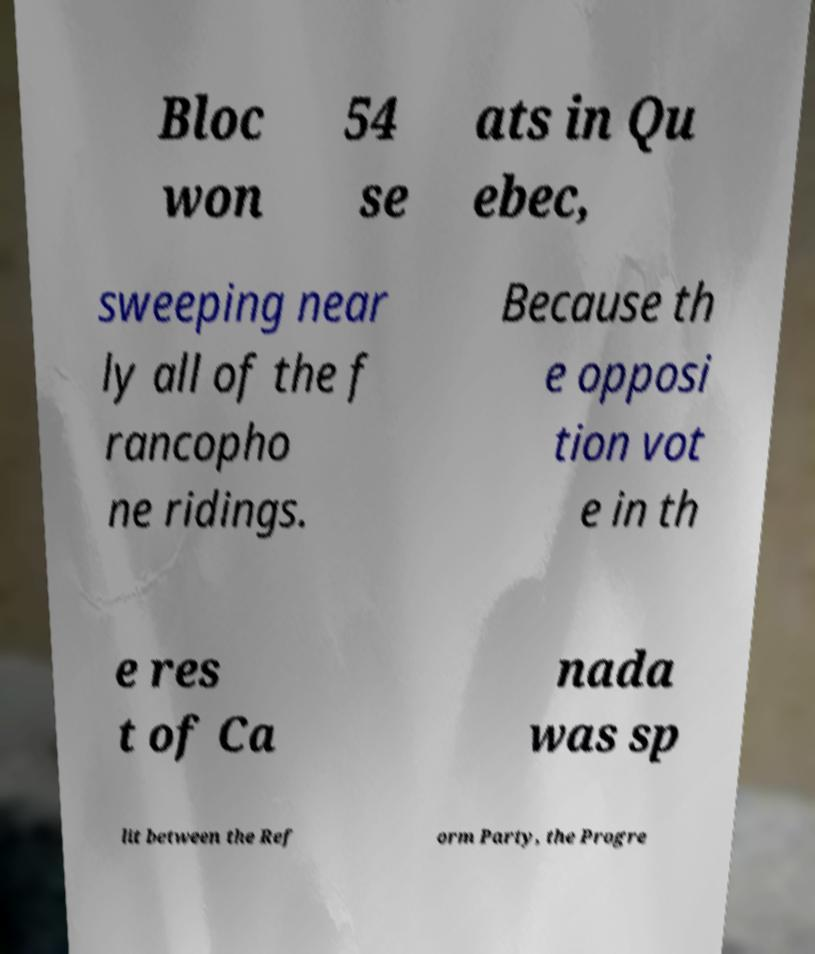For documentation purposes, I need the text within this image transcribed. Could you provide that? Bloc won 54 se ats in Qu ebec, sweeping near ly all of the f rancopho ne ridings. Because th e opposi tion vot e in th e res t of Ca nada was sp lit between the Ref orm Party, the Progre 